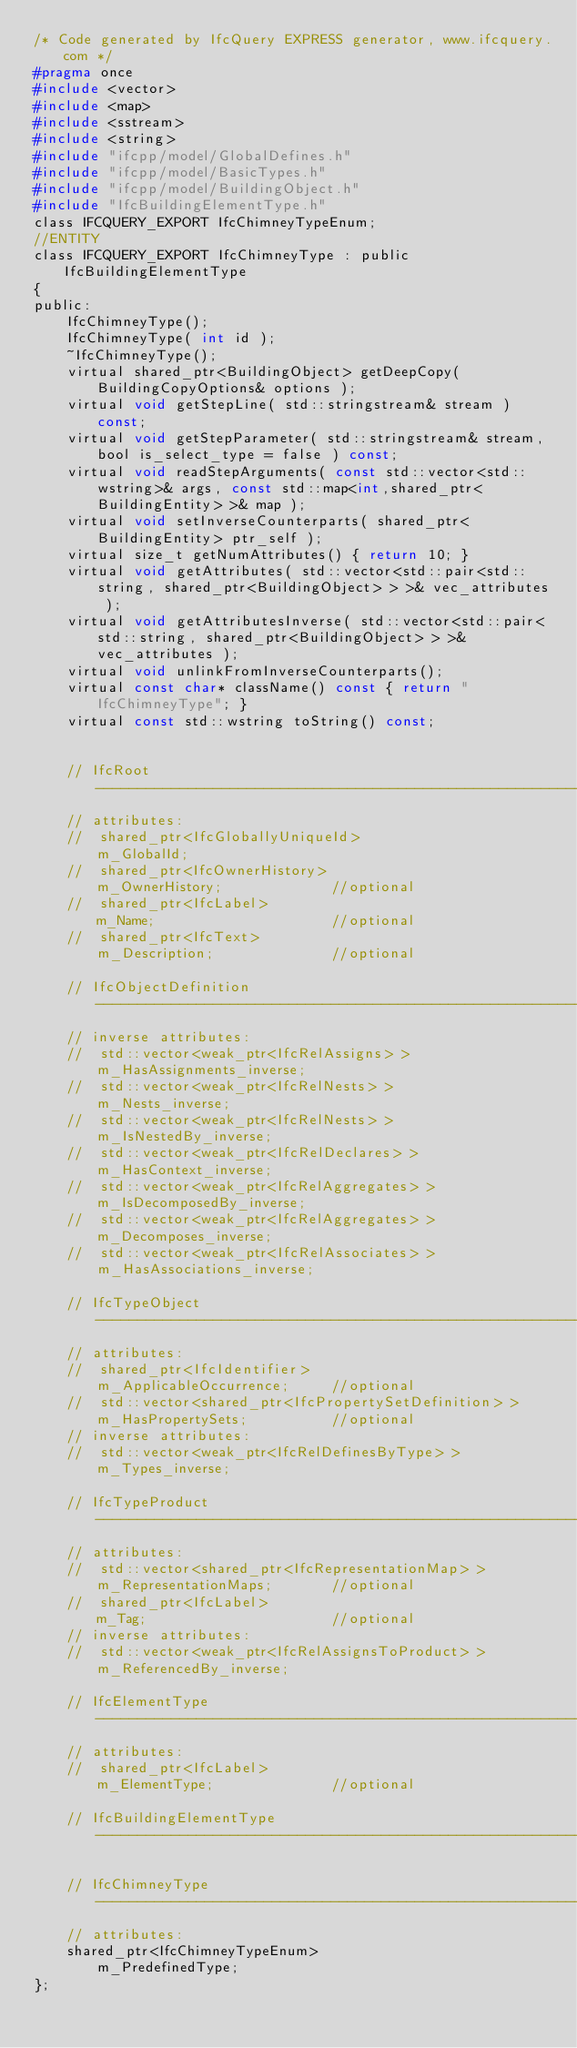Convert code to text. <code><loc_0><loc_0><loc_500><loc_500><_C_>/* Code generated by IfcQuery EXPRESS generator, www.ifcquery.com */
#pragma once
#include <vector>
#include <map>
#include <sstream>
#include <string>
#include "ifcpp/model/GlobalDefines.h"
#include "ifcpp/model/BasicTypes.h"
#include "ifcpp/model/BuildingObject.h"
#include "IfcBuildingElementType.h"
class IFCQUERY_EXPORT IfcChimneyTypeEnum;
//ENTITY
class IFCQUERY_EXPORT IfcChimneyType : public IfcBuildingElementType
{ 
public:
	IfcChimneyType();
	IfcChimneyType( int id );
	~IfcChimneyType();
	virtual shared_ptr<BuildingObject> getDeepCopy( BuildingCopyOptions& options );
	virtual void getStepLine( std::stringstream& stream ) const;
	virtual void getStepParameter( std::stringstream& stream, bool is_select_type = false ) const;
	virtual void readStepArguments( const std::vector<std::wstring>& args, const std::map<int,shared_ptr<BuildingEntity> >& map );
	virtual void setInverseCounterparts( shared_ptr<BuildingEntity> ptr_self );
	virtual size_t getNumAttributes() { return 10; }
	virtual void getAttributes( std::vector<std::pair<std::string, shared_ptr<BuildingObject> > >& vec_attributes );
	virtual void getAttributesInverse( std::vector<std::pair<std::string, shared_ptr<BuildingObject> > >& vec_attributes );
	virtual void unlinkFromInverseCounterparts();
	virtual const char* className() const { return "IfcChimneyType"; }
	virtual const std::wstring toString() const;


	// IfcRoot -----------------------------------------------------------
	// attributes:
	//  shared_ptr<IfcGloballyUniqueId>						m_GlobalId;
	//  shared_ptr<IfcOwnerHistory>							m_OwnerHistory;				//optional
	//  shared_ptr<IfcLabel>								m_Name;						//optional
	//  shared_ptr<IfcText>									m_Description;				//optional

	// IfcObjectDefinition -----------------------------------------------------------
	// inverse attributes:
	//  std::vector<weak_ptr<IfcRelAssigns> >				m_HasAssignments_inverse;
	//  std::vector<weak_ptr<IfcRelNests> >					m_Nests_inverse;
	//  std::vector<weak_ptr<IfcRelNests> >					m_IsNestedBy_inverse;
	//  std::vector<weak_ptr<IfcRelDeclares> >				m_HasContext_inverse;
	//  std::vector<weak_ptr<IfcRelAggregates> >			m_IsDecomposedBy_inverse;
	//  std::vector<weak_ptr<IfcRelAggregates> >			m_Decomposes_inverse;
	//  std::vector<weak_ptr<IfcRelAssociates> >			m_HasAssociations_inverse;

	// IfcTypeObject -----------------------------------------------------------
	// attributes:
	//  shared_ptr<IfcIdentifier>							m_ApplicableOccurrence;		//optional
	//  std::vector<shared_ptr<IfcPropertySetDefinition> >	m_HasPropertySets;			//optional
	// inverse attributes:
	//  std::vector<weak_ptr<IfcRelDefinesByType> >			m_Types_inverse;

	// IfcTypeProduct -----------------------------------------------------------
	// attributes:
	//  std::vector<shared_ptr<IfcRepresentationMap> >		m_RepresentationMaps;		//optional
	//  shared_ptr<IfcLabel>								m_Tag;						//optional
	// inverse attributes:
	//  std::vector<weak_ptr<IfcRelAssignsToProduct> >		m_ReferencedBy_inverse;

	// IfcElementType -----------------------------------------------------------
	// attributes:
	//  shared_ptr<IfcLabel>								m_ElementType;				//optional

	// IfcBuildingElementType -----------------------------------------------------------

	// IfcChimneyType -----------------------------------------------------------
	// attributes:
	shared_ptr<IfcChimneyTypeEnum>						m_PredefinedType;
};

</code> 